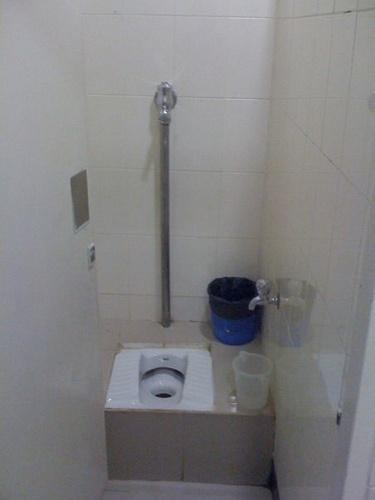Describe the objects in this image and their specific colors. I can see toilet in darkgray and gray tones and bowl in darkgray and gray tones in this image. 